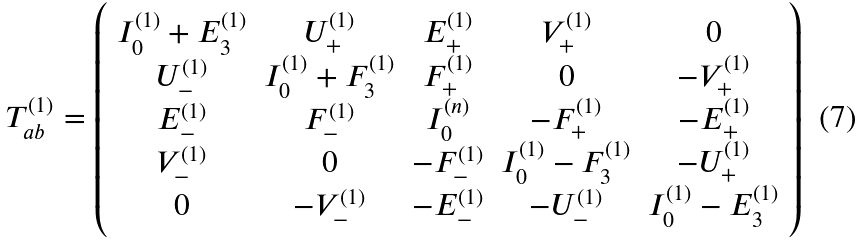Convert formula to latex. <formula><loc_0><loc_0><loc_500><loc_500>T _ { a b } ^ { ( 1 ) } = \left ( \begin{array} { c c c c c } I ^ { ( 1 ) } _ { 0 } + E ^ { ( 1 ) } _ { 3 } & U ^ { ( 1 ) } _ { + } & E ^ { ( 1 ) } _ { + } & V ^ { ( 1 ) } _ { + } & 0 \\ U ^ { ( 1 ) } _ { - } & I ^ { ( 1 ) } _ { 0 } + F ^ { ( 1 ) } _ { 3 } & F ^ { ( 1 ) } _ { + } & 0 & - V ^ { ( 1 ) } _ { + } \\ E ^ { ( 1 ) } _ { - } & F ^ { ( 1 ) } _ { - } & I ^ { ( n ) } _ { 0 } & - F ^ { ( 1 ) } _ { + } & - E ^ { ( 1 ) } _ { + } \\ V ^ { ( 1 ) } _ { - } & 0 & - F ^ { ( 1 ) } _ { - } & I ^ { ( 1 ) } _ { 0 } - F ^ { ( 1 ) } _ { 3 } & - U ^ { ( 1 ) } _ { + } \\ 0 & - V ^ { ( 1 ) } _ { - } & - E ^ { ( 1 ) } _ { - } & - U ^ { ( 1 ) } _ { - } & I ^ { ( 1 ) } _ { 0 } - E ^ { ( 1 ) } _ { 3 } \\ \end{array} \right )</formula> 